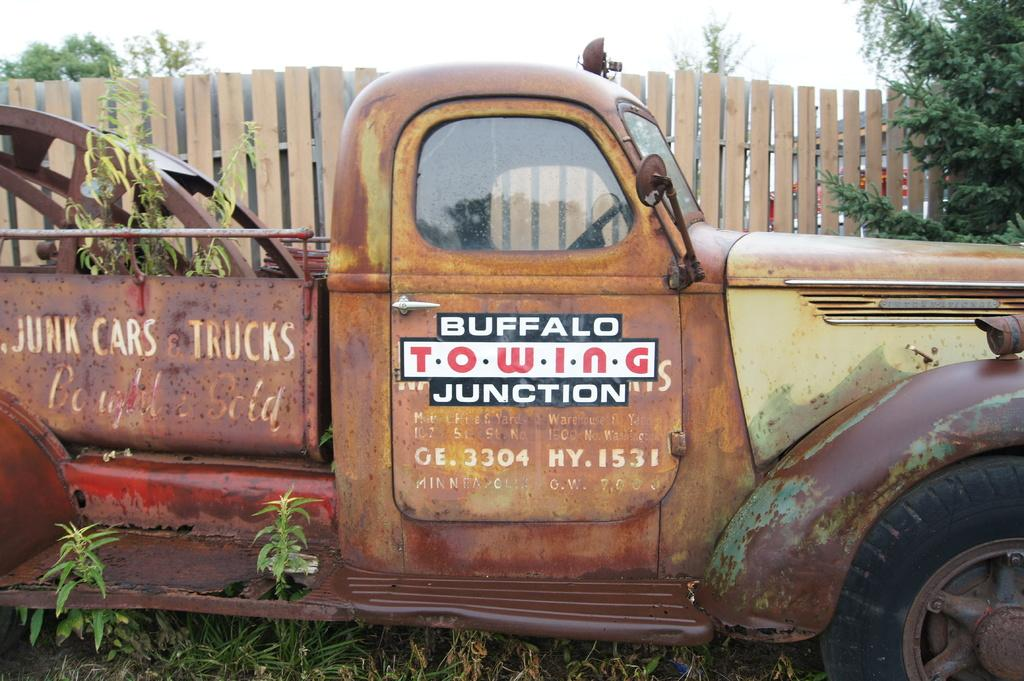What type of vehicle is in the image? There is an old truck in the image. What can be seen on the truck? Something is written on the truck. What is located beside the truck? There is a wooden fence beside the truck. What can be seen in the background of the image? There are trees in the background of the image. How many boys are participating in the competition in the image? There is no competition or boys present in the image; it features an old truck, a wooden fence, and trees in the background. 